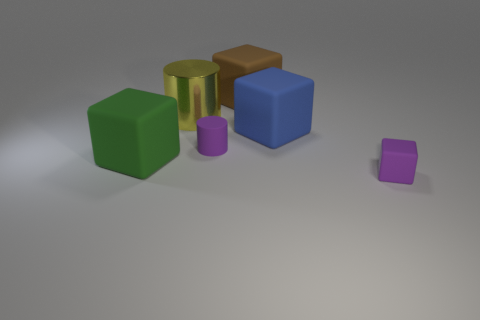How many metallic objects are the same size as the brown matte thing?
Offer a terse response. 1. The rubber object that is the same color as the matte cylinder is what size?
Give a very brief answer. Small. Is there a big metal cylinder that has the same color as the matte cylinder?
Your response must be concise. No. There is a cylinder that is the same size as the purple cube; what is its color?
Offer a terse response. Purple. There is a tiny matte cube; is its color the same as the small rubber cylinder that is behind the tiny rubber block?
Ensure brevity in your answer.  Yes. What is the color of the rubber cylinder?
Make the answer very short. Purple. What material is the small purple thing that is behind the tiny purple matte cube?
Keep it short and to the point. Rubber. The brown matte thing that is the same shape as the green thing is what size?
Your response must be concise. Large. Are there fewer green rubber things that are on the right side of the tiny matte cube than small matte cubes?
Keep it short and to the point. Yes. Are there any blue rubber things?
Provide a succinct answer. Yes. 